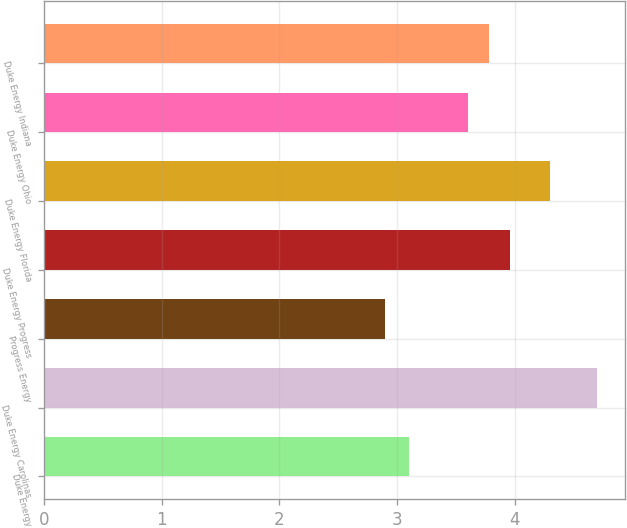Convert chart to OTSL. <chart><loc_0><loc_0><loc_500><loc_500><bar_chart><fcel>Duke Energy<fcel>Duke Energy Carolinas<fcel>Progress Energy<fcel>Duke Energy Progress<fcel>Duke Energy Florida<fcel>Duke Energy Ohio<fcel>Duke Energy Indiana<nl><fcel>3.1<fcel>4.7<fcel>2.9<fcel>3.96<fcel>4.3<fcel>3.6<fcel>3.78<nl></chart> 